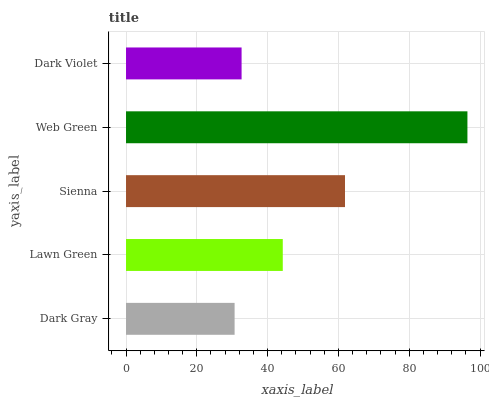Is Dark Gray the minimum?
Answer yes or no. Yes. Is Web Green the maximum?
Answer yes or no. Yes. Is Lawn Green the minimum?
Answer yes or no. No. Is Lawn Green the maximum?
Answer yes or no. No. Is Lawn Green greater than Dark Gray?
Answer yes or no. Yes. Is Dark Gray less than Lawn Green?
Answer yes or no. Yes. Is Dark Gray greater than Lawn Green?
Answer yes or no. No. Is Lawn Green less than Dark Gray?
Answer yes or no. No. Is Lawn Green the high median?
Answer yes or no. Yes. Is Lawn Green the low median?
Answer yes or no. Yes. Is Dark Violet the high median?
Answer yes or no. No. Is Dark Violet the low median?
Answer yes or no. No. 